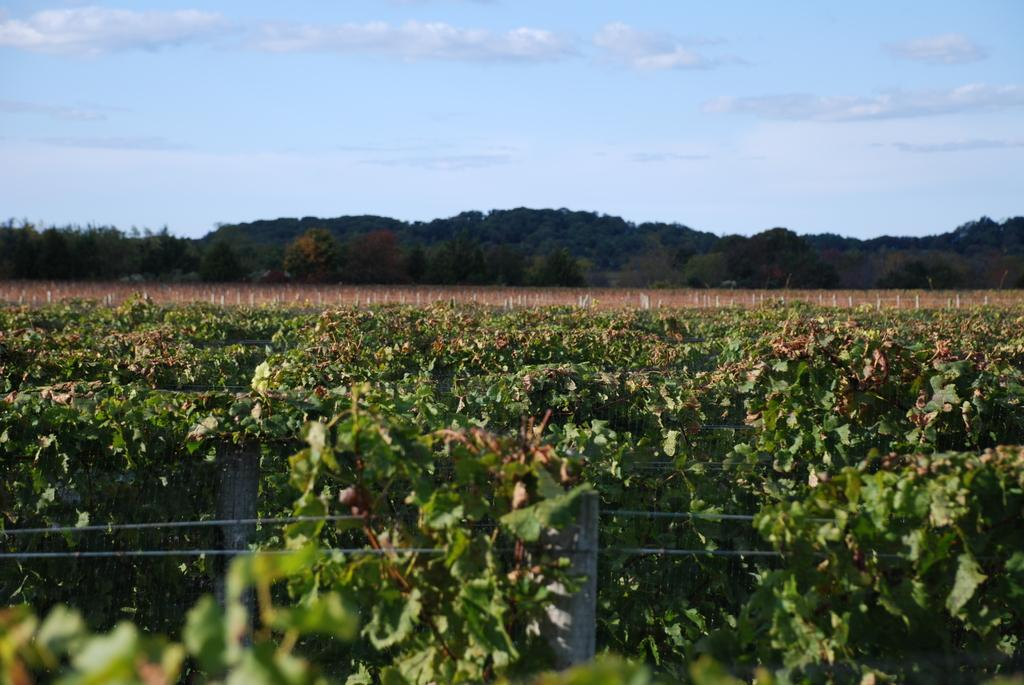What type of living organisms can be seen in the image? The image contains many plants. What can be seen in the background of the image? There are trees in the background of the image. What is visible in the sky at the top of the image? Clouds are visible in the sky at the top of the image. What type of advertisement can be seen on the dinosaurs in the image? There are no dinosaurs present in the image, so there cannot be any advertisements on them. 